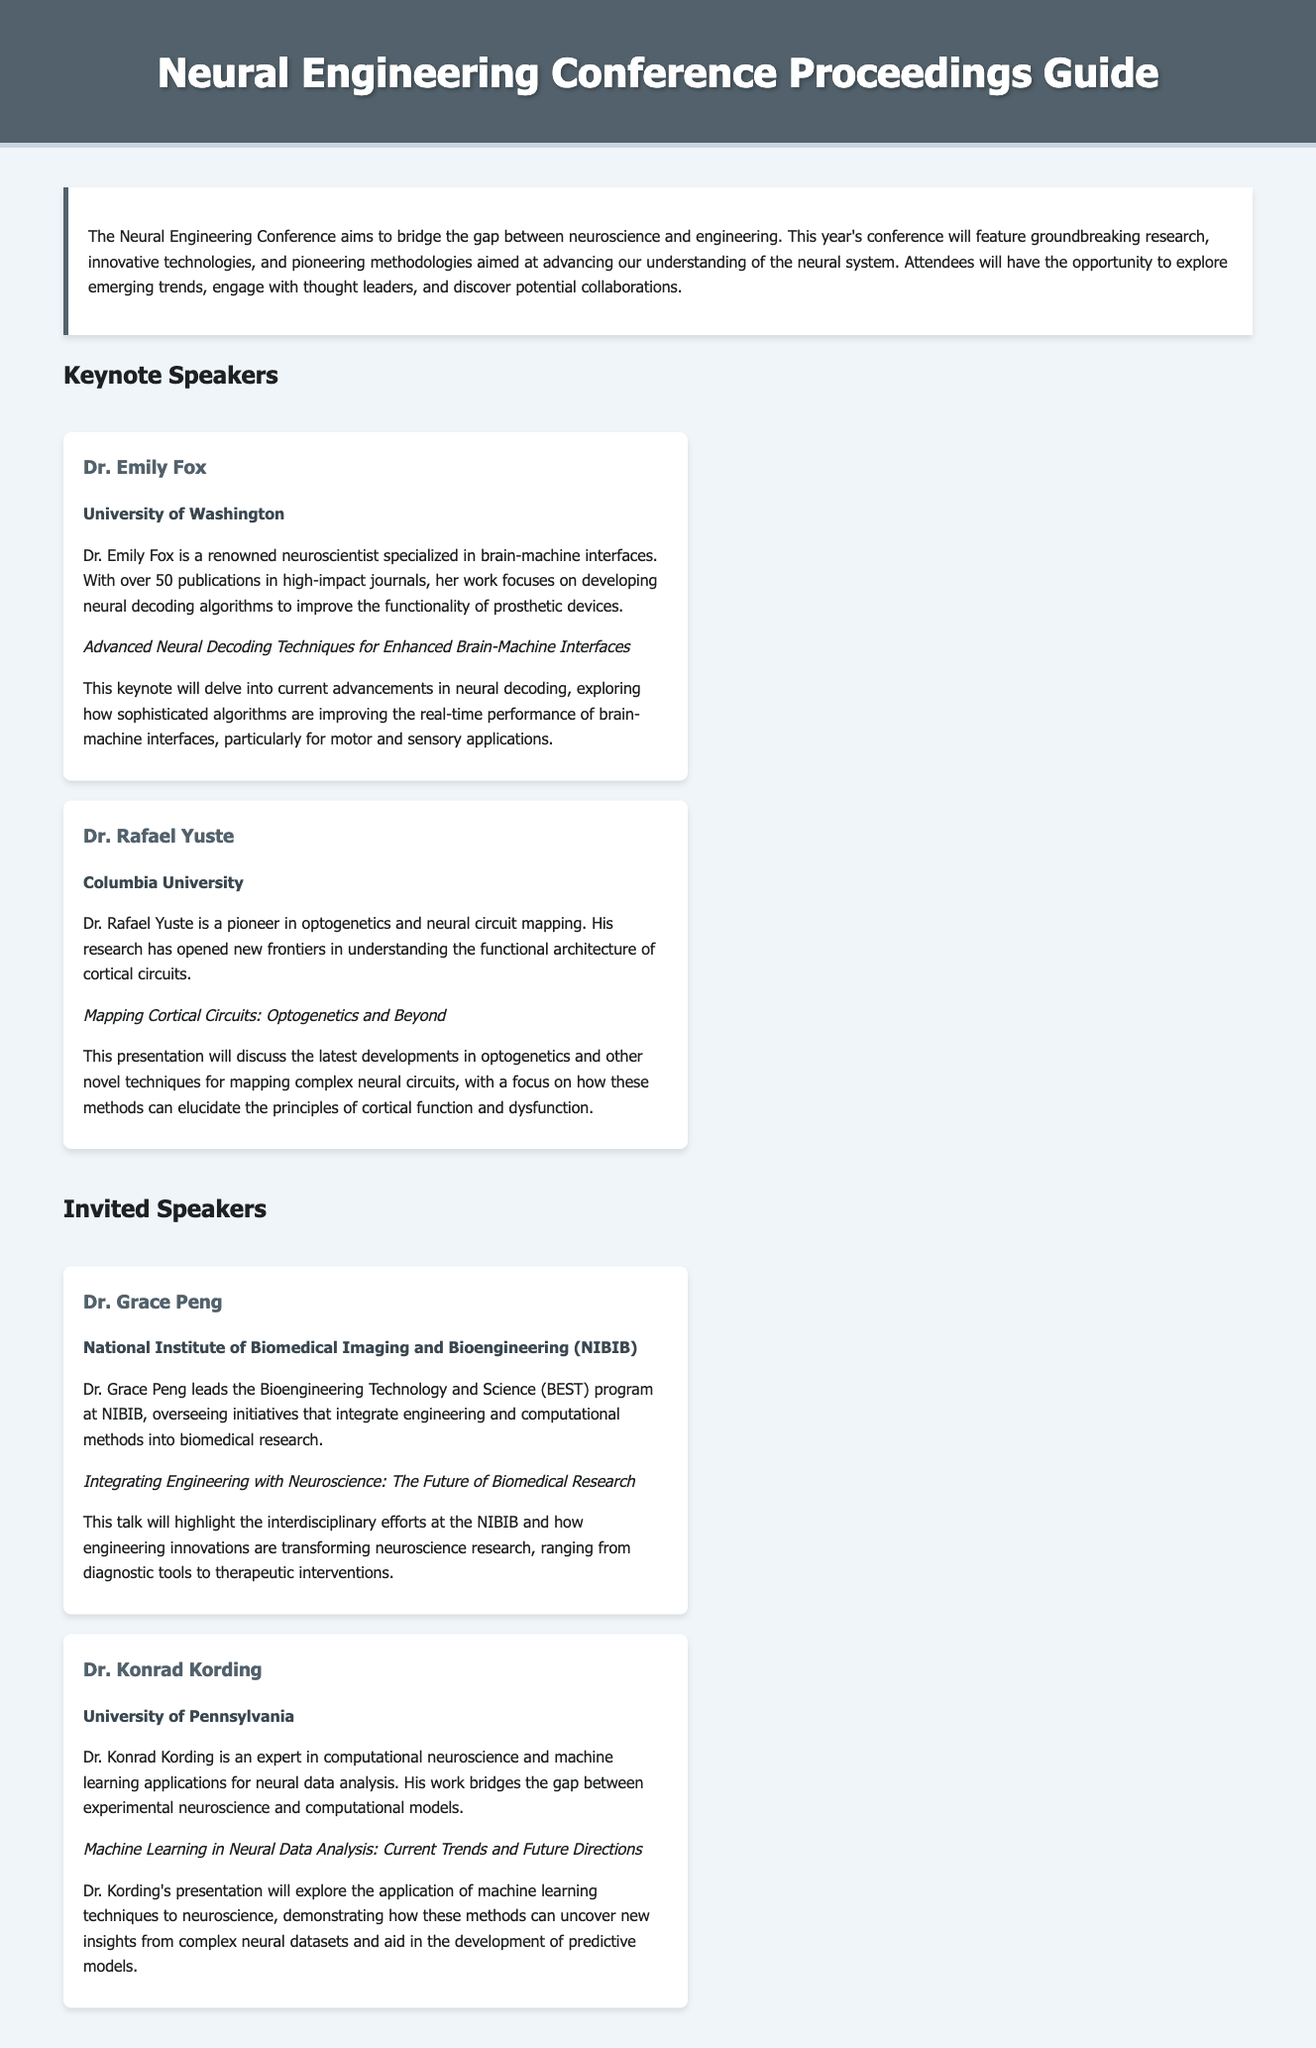What is the title of the guide? The title of the document is stated in the header section of the HTML, which captures the overarching theme of the event.
Answer: Neural Engineering Conference Proceedings Guide Who is a keynote speaker from the University of Washington? The document lists keynote speakers and their affiliations, providing specific names with their corresponding institutions.
Answer: Dr. Emily Fox What is the affiliation of Dr. Rafael Yuste? The affiliation of Dr. Rafael Yuste is mentioned directly after his name in the speaker section of the document.
Answer: Columbia University What is the talk title of Dr. Grace Peng? The document specifies talk titles for each speaker, showcasing the topics they will present on during the conference.
Answer: Integrating Engineering with Neuroscience: The Future of Biomedical Research How many publications does Dr. Emily Fox have? The document indicates the number of publications in high-impact journals attributed to Dr. Emily Fox, providing a quantitative measure of her contributions.
Answer: Over 50 What topic will Dr. Kording's presentation explore? The document outlines the focus of Dr. Kording's talk, revealing insights into the use of technology in neuroscience research.
Answer: Machine Learning in Neural Data Analysis: Current Trends and Future Directions What theme does the Neural Engineering Conference aim to bridge? The document describes the primary aim of the conference, highlighting an essential aspect of its purpose regarding different fields.
Answer: The gap between neuroscience and engineering What program does Dr. Grace Peng lead at NIBIB? The document specifies Dr. Grace Peng's role in overseeing specific initiatives at the NIBIB, revealing her focus area within the organization.
Answer: Bioengineering Technology and Science (BEST) program What type of research is Dr. Rafael Yuste associated with? The document captures the main research focus of Dr. Rafael Yuste, outlining his contributions to neuroscience methodologies.
Answer: Optogenetics and neural circuit mapping 